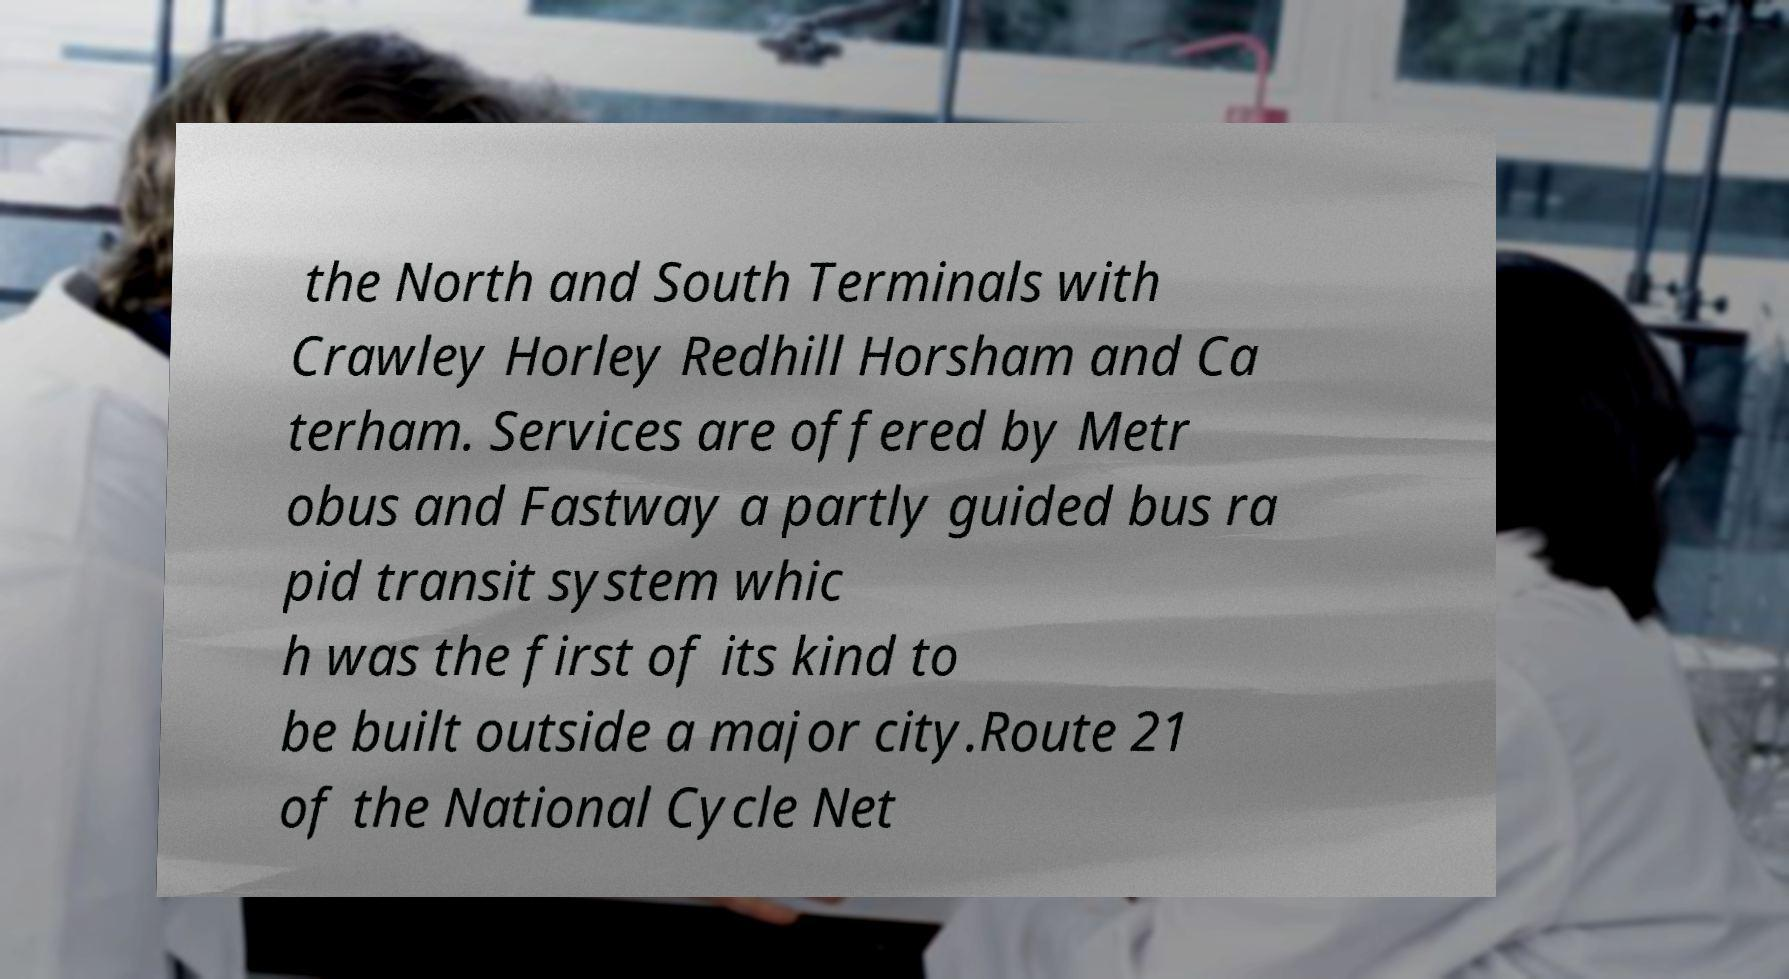Please read and relay the text visible in this image. What does it say? the North and South Terminals with Crawley Horley Redhill Horsham and Ca terham. Services are offered by Metr obus and Fastway a partly guided bus ra pid transit system whic h was the first of its kind to be built outside a major city.Route 21 of the National Cycle Net 